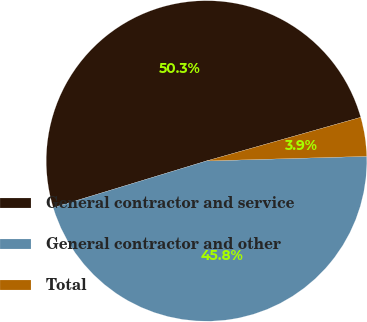Convert chart to OTSL. <chart><loc_0><loc_0><loc_500><loc_500><pie_chart><fcel>General contractor and service<fcel>General contractor and other<fcel>Total<nl><fcel>50.32%<fcel>45.75%<fcel>3.93%<nl></chart> 